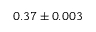Convert formula to latex. <formula><loc_0><loc_0><loc_500><loc_500>0 . 3 7 \pm 0 . 0 0 3</formula> 